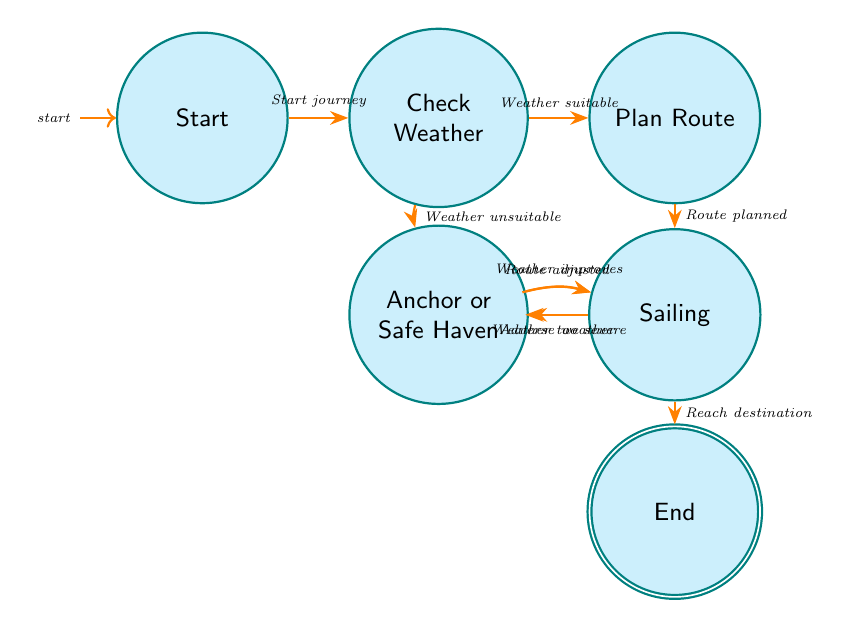What is the initial state in the diagram? The initial state in the diagram is labeled "Start," which denotes the point where the sailing journey begins.
Answer: Start How many states are there in the diagram? Counting each distinct state in the diagram, there are a total of seven states: Start, Check Weather, Plan Route, Sailing, Adjust Route, Anchor or Safe Haven, and End.
Answer: 7 What condition leads from "Check Weather" to "Plan Route"? The transition condition that leads from "Check Weather" to "Plan Route" is that the weather must be suitable for sailing.
Answer: Weather suitable What is the next state if "Sailing" encounters adverse weather? If "Sailing" encounters adverse weather, the next state will be "Adjust Route," where the route will be modified to respond to the adverse conditions.
Answer: Adjust Route How does one return to "Sailing" from "Anchor or Safe Haven"? To return to "Sailing" from "Anchor or Safe Haven," the condition that needs to be met is that the weather improves, indicating it's safe to continue sailing.
Answer: Weather improves What is the terminating condition in the state machine? The terminating condition in the state machine is reaching the destination safely, which leads to the "End" state.
Answer: Reach destination What happens after planning the route? After planning the route, the next step, based on the transition, is to enter the "Sailing" state where the journey progresses according to the planned route.
Answer: Sailing What two conditions can be evaluated in "Check Weather"? In "Check Weather," the two conditions that can be evaluated are whether the weather is suitable or unsuitable for sailing.
Answer: Weather suitable, Weather unsuitable What state follows "Adjust Route"? Following "Adjust Route," the process returns back to "Sailing" if the route has been successfully adjusted.
Answer: Sailing 